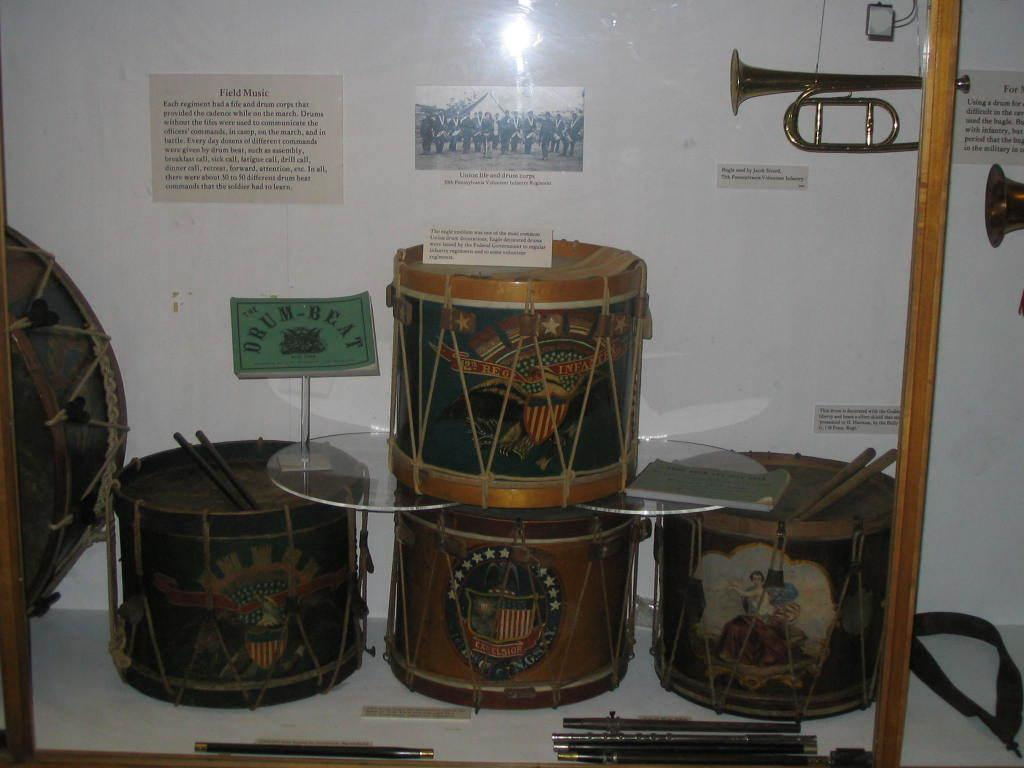What musical instruments are visible on the shelf in the image? There are drums and sticks arranged on a shelf at the bottom of the image. How is the shelf protected or covered? The shelf is covered with a glass. What can be seen on the wall in the background of the image? There are posters on a white wall in the background of the image. Can you see any smoke coming from the drums in the image? There is no smoke present in the image; it only features drums, sticks, a shelf, and posters on a wall. 